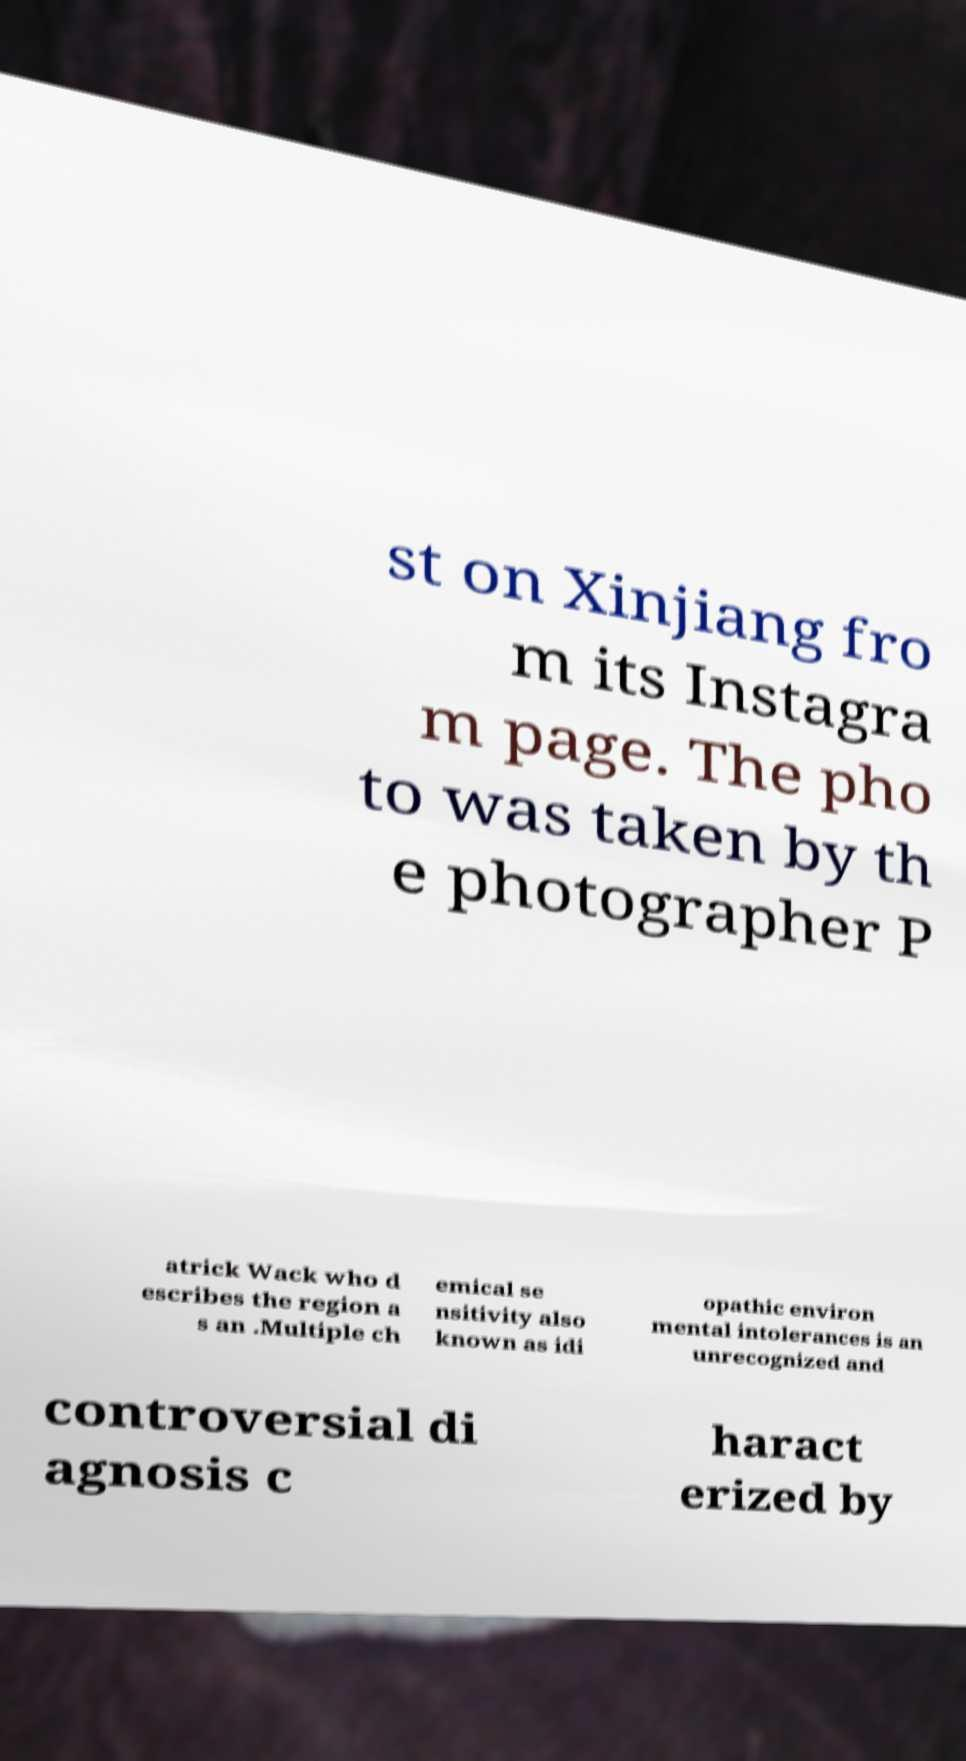What messages or text are displayed in this image? I need them in a readable, typed format. st on Xinjiang fro m its Instagra m page. The pho to was taken by th e photographer P atrick Wack who d escribes the region a s an .Multiple ch emical se nsitivity also known as idi opathic environ mental intolerances is an unrecognized and controversial di agnosis c haract erized by 